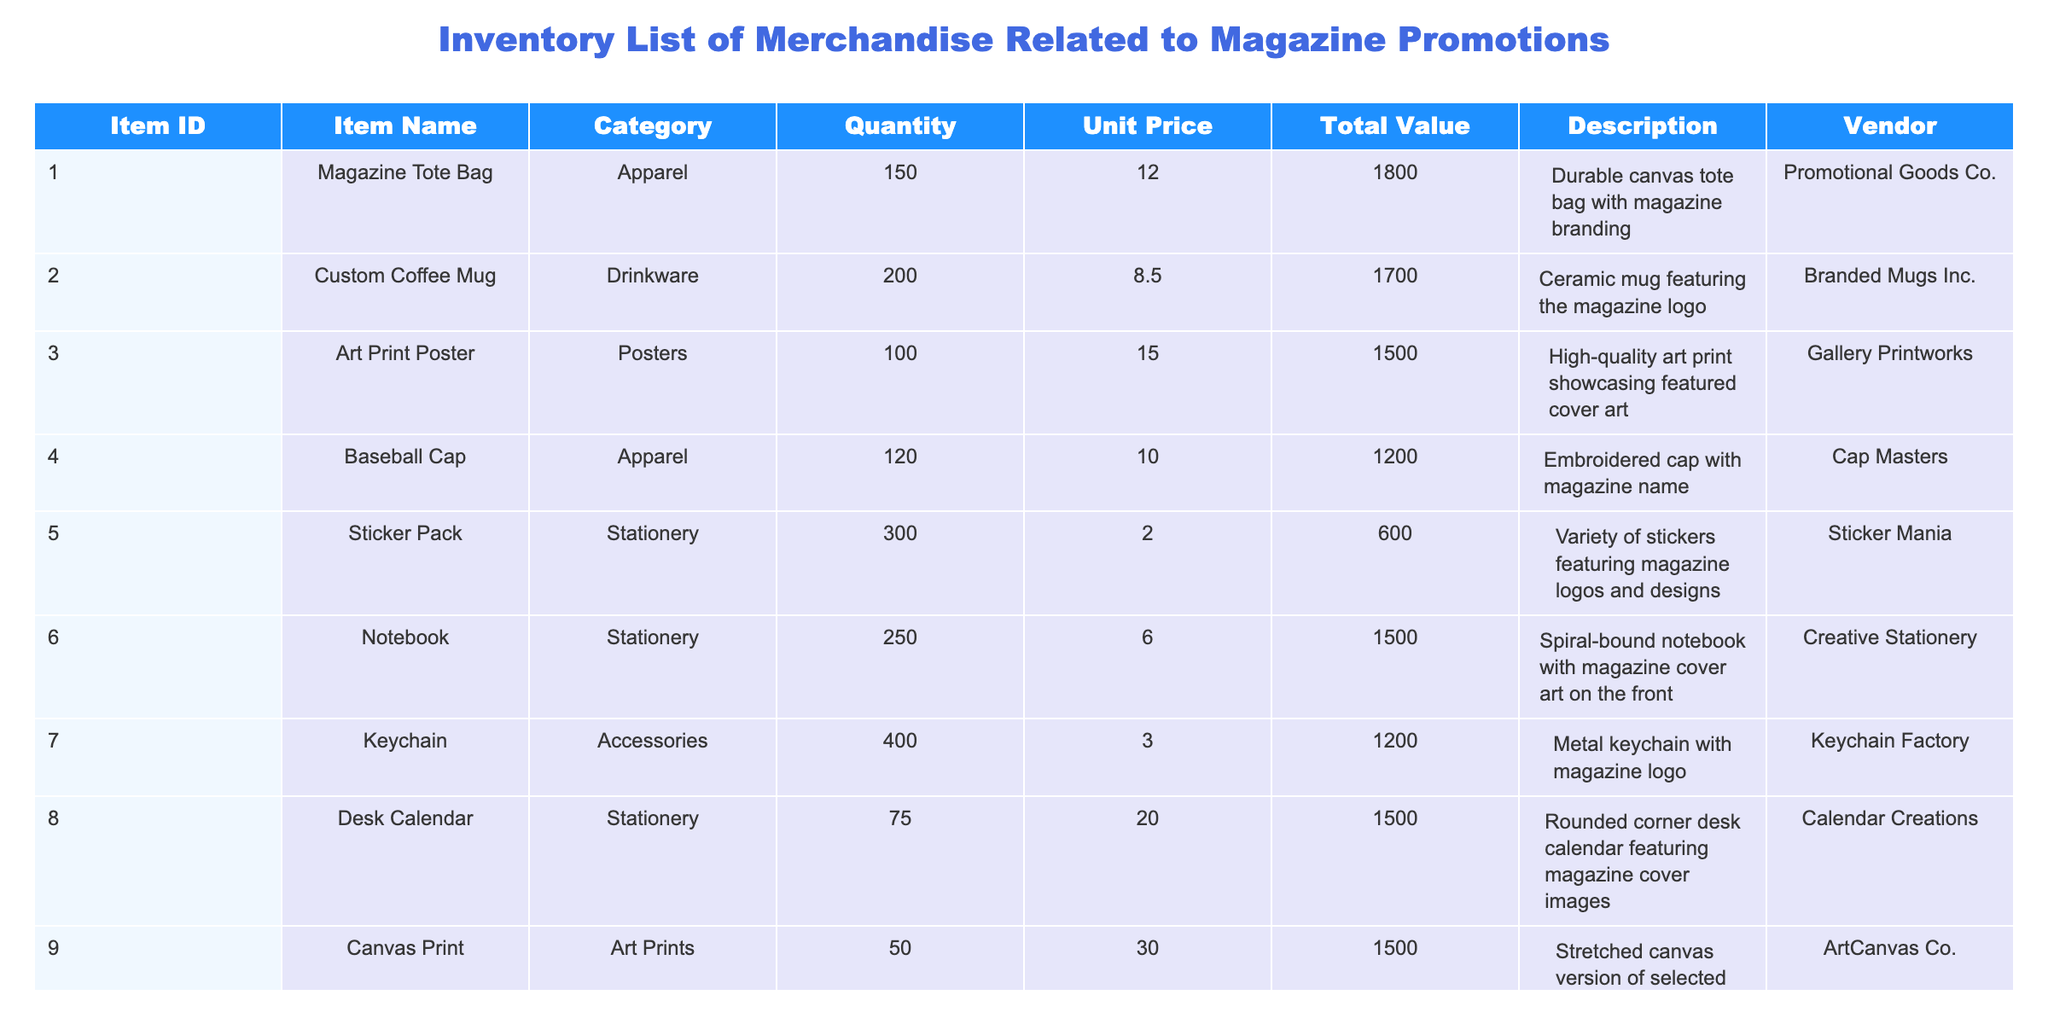What is the total quantity of all items listed in the inventory? To find the total quantity, we need to sum up the quantities of all items in the table: 150 + 200 + 100 + 120 + 300 + 250 + 400 + 75 + 50 + 180 = 1875.
Answer: 1875 Which item has the highest total value? The total values for each item are: Tote Bag 1800, Coffee Mug 1700, Art Print Poster 1500, Baseball Cap 1200, Sticker Pack 600, Notebook 1500, Keychain 1200, Desk Calendar 1500, Canvas Print 1500, and T-Shirt 2700. The highest value is for the T-Shirt at 2700.
Answer: T-Shirt Is there a stationery item that has a quantity greater than 250? The quantities for stationery items are: Sticker Pack 300, Notebook 250, and Desk Calendar 75. Only the Sticker Pack (300) has a quantity greater than 250, so the answer is yes.
Answer: Yes What is the average unit price for apparel items? The unit prices for apparel items are: Tote Bag 12.00, Baseball Cap 10.00, and T-Shirt 15.00. The average unit price is calculated as (12 + 10 + 15) / 3 = 12.33.
Answer: 12.33 How many total items are either in the Apparel or Stationery category? The Apparel category has 3 items (Tote Bag, Baseball Cap, T-Shirt) and Stationery has 3 items (Sticker Pack, Notebook, Desk Calendar). Summing them gives 3 + 3 = 6.
Answer: 6 What is the total value of drinkware items in the inventory? The only drinkware item listed is the Custom Coffee Mug, which has a total value of 1700. Therefore, the total value for drinkware items is simply 1700.
Answer: 1700 Are there any items that have a unit price less than 5.00? The unit prices for the items are: Tote Bag 12.00, Coffee Mug 8.50, Art Print Poster 15.00, Baseball Cap 10.00, Sticker Pack 2.00, Notebook 6.00, Keychain 3.00, Desk Calendar 20.00, Canvas Print 30.00, and T-Shirt 15.00. The Sticker Pack (2.00) and Keychain (3.00) are both less than 5.00, making the answer yes.
Answer: Yes What is the combined total value of items in the Accessories category? The only item in the Accessories category is the Keychain, which has a total value of 1200. Therefore, the combined total value of this category is 1200.
Answer: 1200 Which vendor supplies the Notebook item? The vendor listed for the Notebook item is Creative Stationery.
Answer: Creative Stationery 